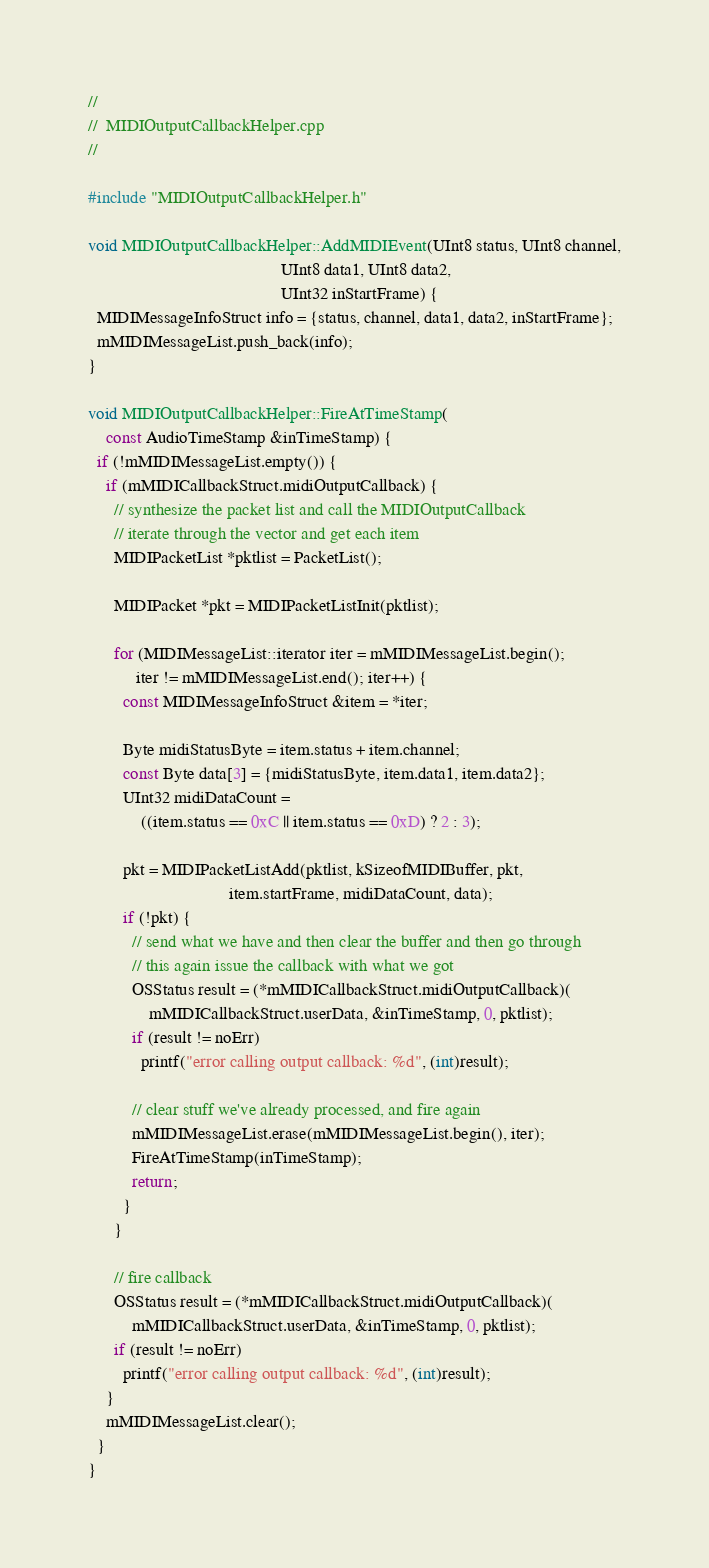Convert code to text. <code><loc_0><loc_0><loc_500><loc_500><_C++_>//
//  MIDIOutputCallbackHelper.cpp
//

#include "MIDIOutputCallbackHelper.h"

void MIDIOutputCallbackHelper::AddMIDIEvent(UInt8 status, UInt8 channel,
                                            UInt8 data1, UInt8 data2,
                                            UInt32 inStartFrame) {
  MIDIMessageInfoStruct info = {status, channel, data1, data2, inStartFrame};
  mMIDIMessageList.push_back(info);
}

void MIDIOutputCallbackHelper::FireAtTimeStamp(
    const AudioTimeStamp &inTimeStamp) {
  if (!mMIDIMessageList.empty()) {
    if (mMIDICallbackStruct.midiOutputCallback) {
      // synthesize the packet list and call the MIDIOutputCallback
      // iterate through the vector and get each item
      MIDIPacketList *pktlist = PacketList();

      MIDIPacket *pkt = MIDIPacketListInit(pktlist);

      for (MIDIMessageList::iterator iter = mMIDIMessageList.begin();
           iter != mMIDIMessageList.end(); iter++) {
        const MIDIMessageInfoStruct &item = *iter;

        Byte midiStatusByte = item.status + item.channel;
        const Byte data[3] = {midiStatusByte, item.data1, item.data2};
        UInt32 midiDataCount =
            ((item.status == 0xC || item.status == 0xD) ? 2 : 3);

        pkt = MIDIPacketListAdd(pktlist, kSizeofMIDIBuffer, pkt,
                                item.startFrame, midiDataCount, data);
        if (!pkt) {
          // send what we have and then clear the buffer and then go through
          // this again issue the callback with what we got
          OSStatus result = (*mMIDICallbackStruct.midiOutputCallback)(
              mMIDICallbackStruct.userData, &inTimeStamp, 0, pktlist);
          if (result != noErr)
            printf("error calling output callback: %d", (int)result);

          // clear stuff we've already processed, and fire again
          mMIDIMessageList.erase(mMIDIMessageList.begin(), iter);
          FireAtTimeStamp(inTimeStamp);
          return;
        }
      }

      // fire callback
      OSStatus result = (*mMIDICallbackStruct.midiOutputCallback)(
          mMIDICallbackStruct.userData, &inTimeStamp, 0, pktlist);
      if (result != noErr)
        printf("error calling output callback: %d", (int)result);
    }
    mMIDIMessageList.clear();
  }
}
</code> 